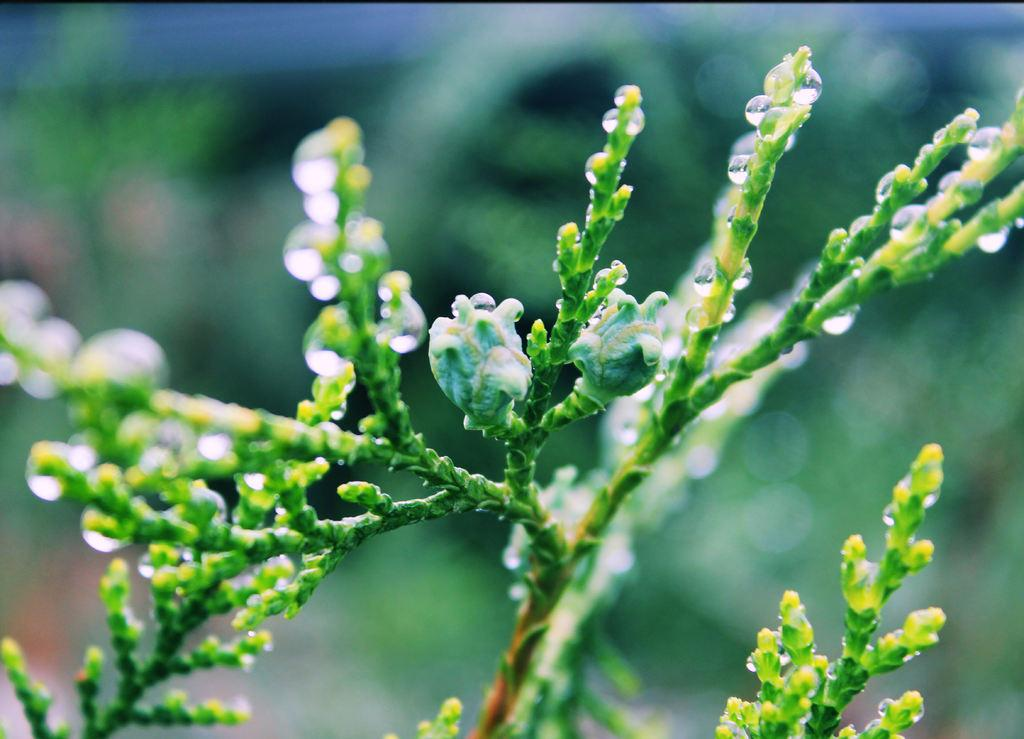What is present in the image? There is a plant in the image. What is the current state of the plant? The plant has buds and water drops on it. Can you describe the background of the image? The background of the image is blurred. What type of net can be seen surrounding the plant in the image? There is no net present in the image; it only features a plant with buds and water drops, and a blurred background. 